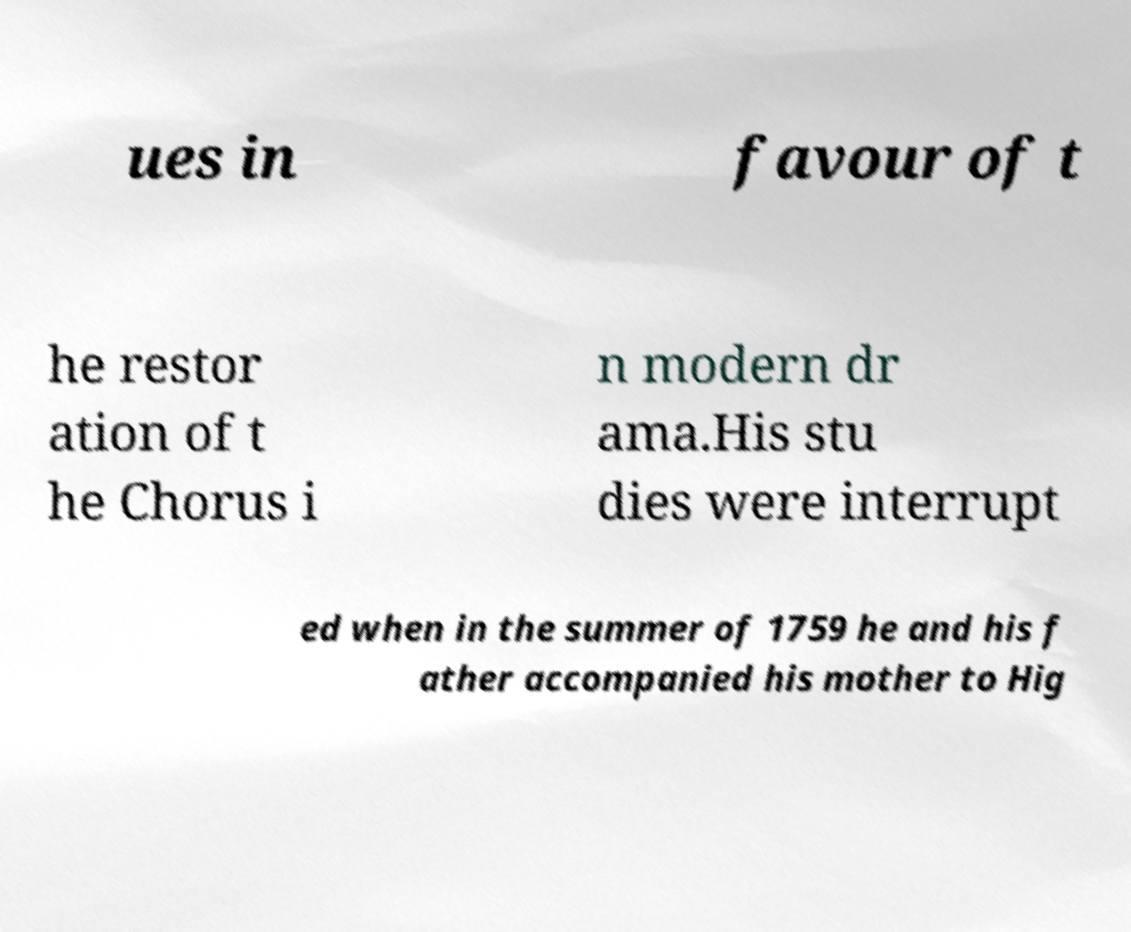Can you read and provide the text displayed in the image?This photo seems to have some interesting text. Can you extract and type it out for me? ues in favour of t he restor ation of t he Chorus i n modern dr ama.His stu dies were interrupt ed when in the summer of 1759 he and his f ather accompanied his mother to Hig 